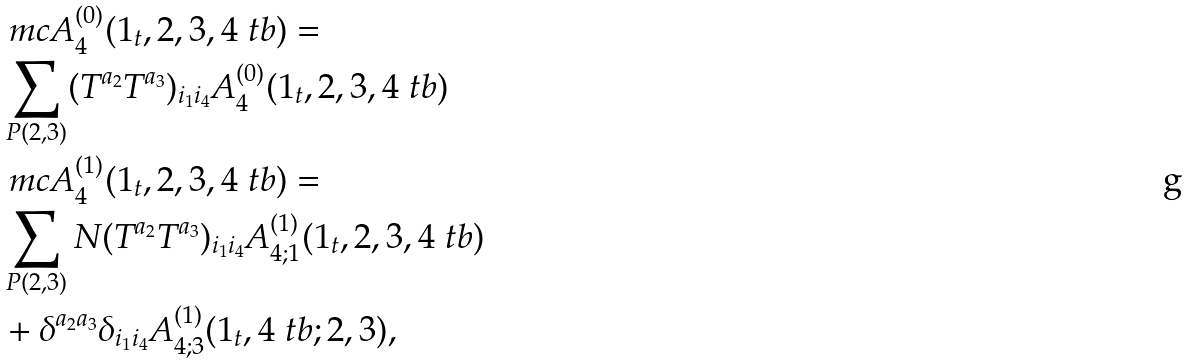<formula> <loc_0><loc_0><loc_500><loc_500>& \ m c A ^ { ( 0 ) } _ { 4 } ( 1 _ { t } , 2 , 3 , 4 _ { \ } t b ) = \\ & \sum _ { P ( 2 , 3 ) } ( T ^ { a _ { 2 } } T ^ { a _ { 3 } } ) _ { i _ { 1 } i _ { 4 } } A ^ { ( 0 ) } _ { 4 } ( 1 _ { t } , 2 , 3 , 4 _ { \ } t b ) \\ & \ m c A ^ { ( 1 ) } _ { 4 } ( 1 _ { t } , 2 , 3 , 4 _ { \ } t b ) = \\ & \sum _ { P ( 2 , 3 ) } N ( T ^ { a _ { 2 } } T ^ { a _ { 3 } } ) _ { i _ { 1 } i _ { 4 } } A ^ { ( 1 ) } _ { 4 ; 1 } ( 1 _ { t } , 2 , 3 , 4 _ { \ } t b ) \\ & + \delta ^ { a _ { 2 } a _ { 3 } } \delta _ { i _ { 1 } i _ { 4 } } A ^ { ( 1 ) } _ { 4 ; 3 } ( 1 _ { t } , 4 _ { \ } t b ; 2 , 3 ) ,</formula> 